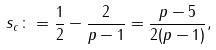<formula> <loc_0><loc_0><loc_500><loc_500>s _ { c } \colon = \frac { 1 } { 2 } - \frac { 2 } { p - 1 } = \frac { p - 5 } { 2 ( p - 1 ) } ,</formula> 